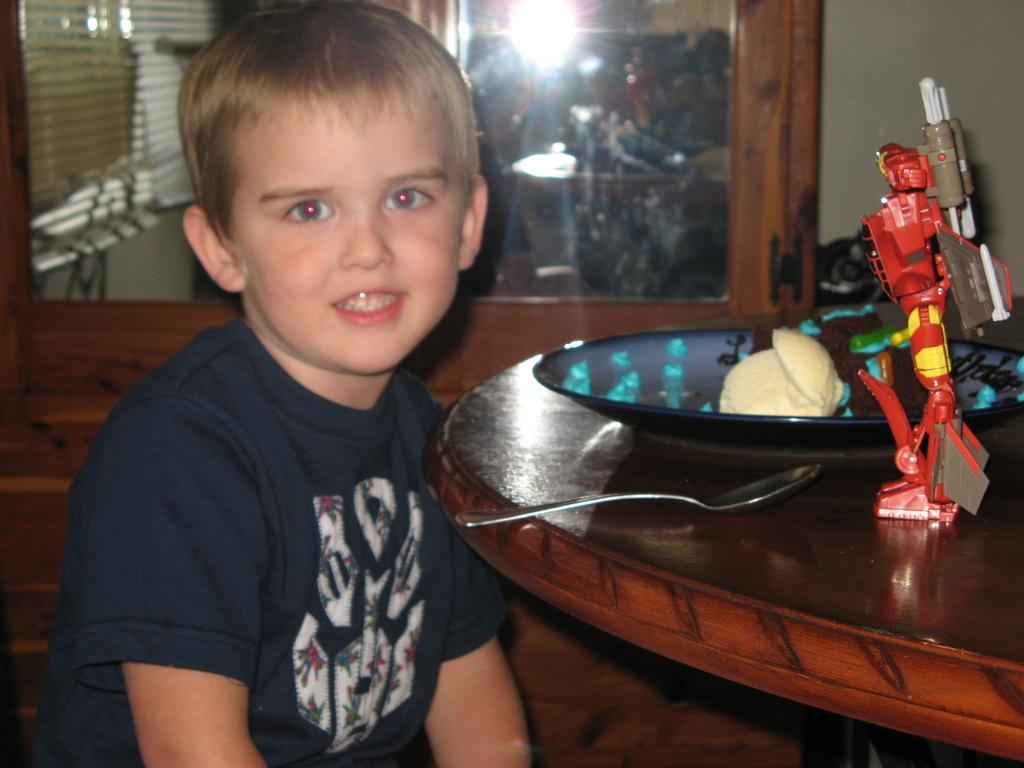Who is present in the image? There is a boy in the image. What is in front of the boy? There is a table in front of the boy. What objects are on the table? There is a toy and a bowl on the table. What utensil is on the table? There is a spoon on the table. What type of crime is being committed in the image? There is no crime being committed in the image; it features a boy, a table, and various objects on the table. 